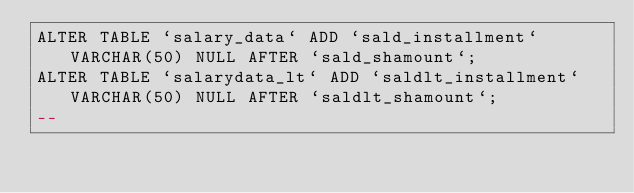<code> <loc_0><loc_0><loc_500><loc_500><_SQL_>ALTER TABLE `salary_data` ADD `sald_installment` VARCHAR(50) NULL AFTER `sald_shamount`;
ALTER TABLE `salarydata_lt` ADD `saldlt_installment` VARCHAR(50) NULL AFTER `saldlt_shamount`;
-- 
</code> 